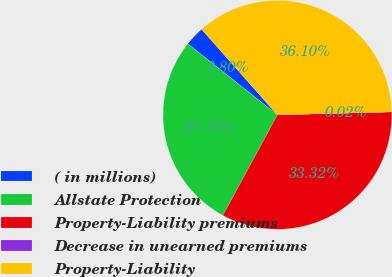<chart> <loc_0><loc_0><loc_500><loc_500><pie_chart><fcel>( in millions)<fcel>Allstate Protection<fcel>Property-Liability premiums<fcel>Decrease in unearned premiums<fcel>Property-Liability<nl><fcel>2.8%<fcel>27.76%<fcel>33.32%<fcel>0.02%<fcel>36.1%<nl></chart> 